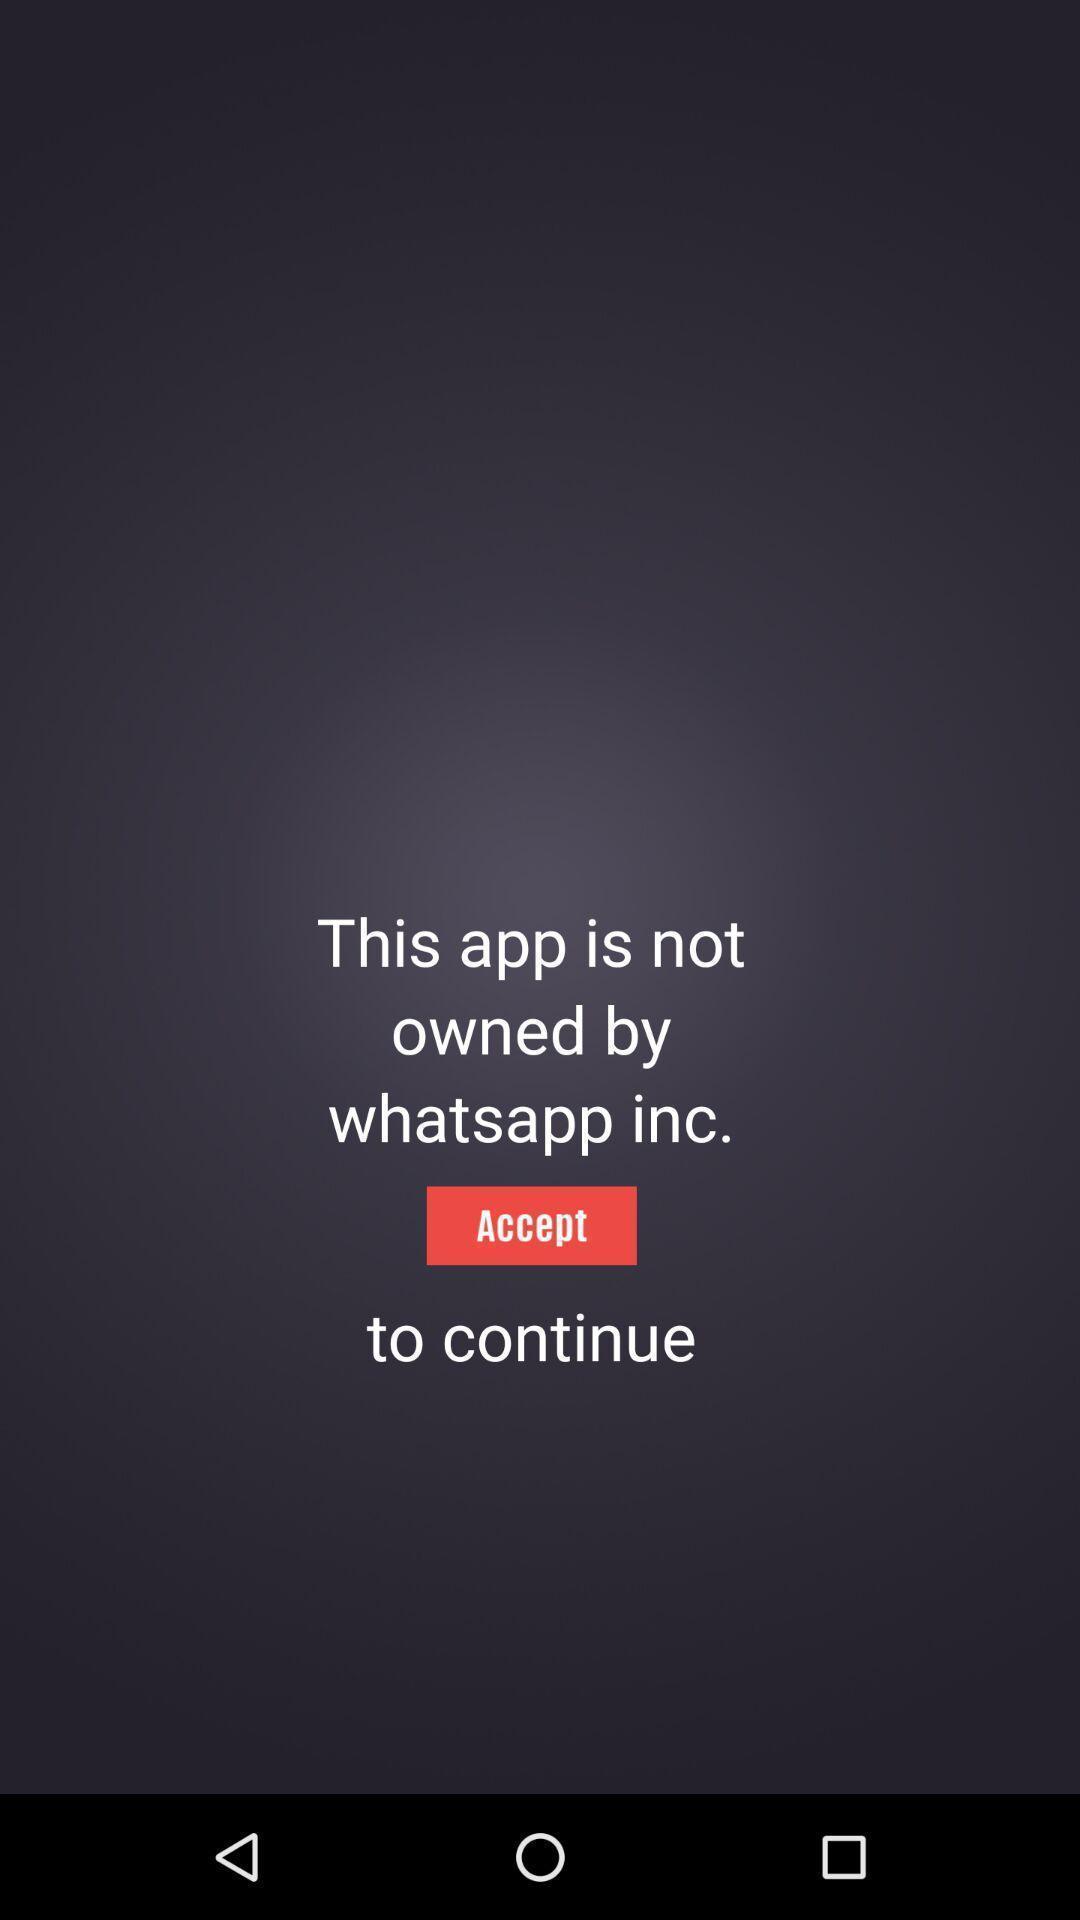Give me a narrative description of this picture. Page showing option like accept. 